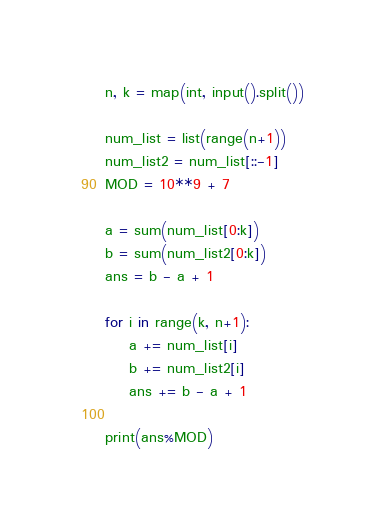Convert code to text. <code><loc_0><loc_0><loc_500><loc_500><_Python_>n, k = map(int, input().split())

num_list = list(range(n+1))
num_list2 = num_list[::-1]
MOD = 10**9 + 7

a = sum(num_list[0:k])
b = sum(num_list2[0:k])
ans = b - a + 1

for i in range(k, n+1):
    a += num_list[i]
    b += num_list2[i]
    ans += b - a + 1

print(ans%MOD)</code> 